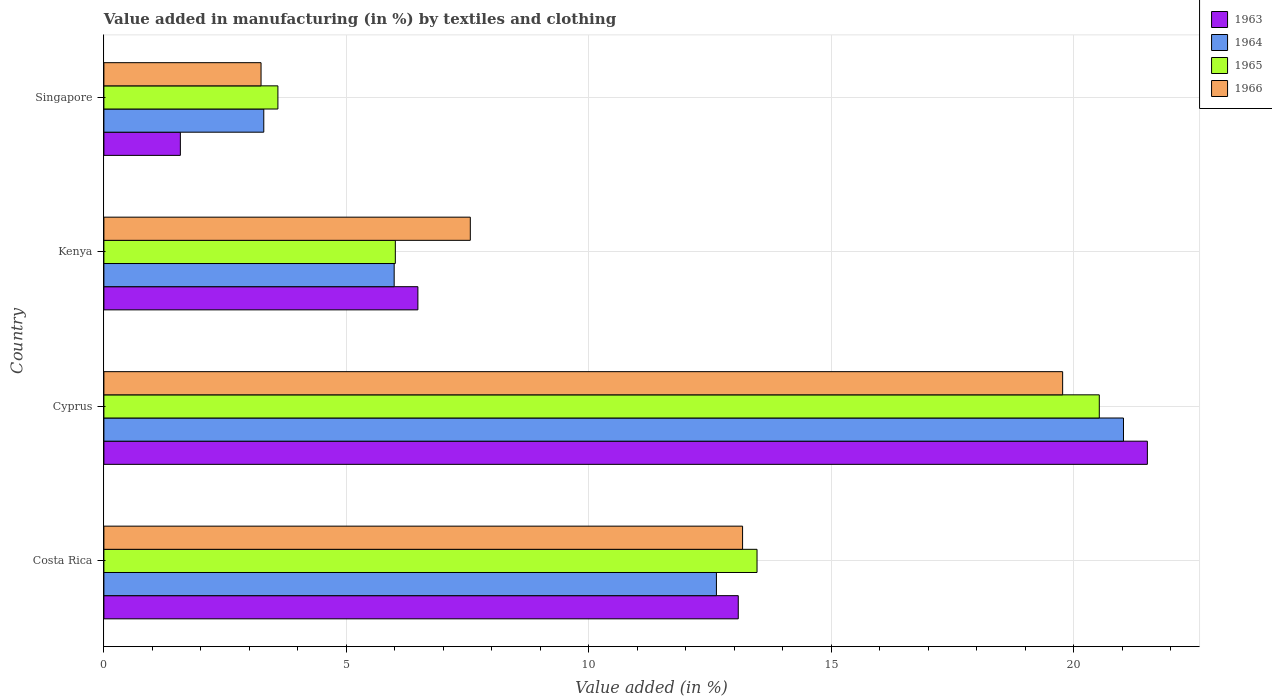How many groups of bars are there?
Your answer should be compact. 4. Are the number of bars on each tick of the Y-axis equal?
Offer a very short reply. Yes. How many bars are there on the 4th tick from the top?
Ensure brevity in your answer.  4. How many bars are there on the 4th tick from the bottom?
Your response must be concise. 4. What is the label of the 1st group of bars from the top?
Your response must be concise. Singapore. What is the percentage of value added in manufacturing by textiles and clothing in 1963 in Cyprus?
Your answer should be very brief. 21.52. Across all countries, what is the maximum percentage of value added in manufacturing by textiles and clothing in 1964?
Provide a succinct answer. 21.03. Across all countries, what is the minimum percentage of value added in manufacturing by textiles and clothing in 1964?
Provide a succinct answer. 3.3. In which country was the percentage of value added in manufacturing by textiles and clothing in 1963 maximum?
Make the answer very short. Cyprus. In which country was the percentage of value added in manufacturing by textiles and clothing in 1965 minimum?
Your answer should be very brief. Singapore. What is the total percentage of value added in manufacturing by textiles and clothing in 1963 in the graph?
Your answer should be compact. 42.66. What is the difference between the percentage of value added in manufacturing by textiles and clothing in 1966 in Cyprus and that in Singapore?
Offer a very short reply. 16.53. What is the difference between the percentage of value added in manufacturing by textiles and clothing in 1964 in Cyprus and the percentage of value added in manufacturing by textiles and clothing in 1965 in Costa Rica?
Your answer should be compact. 7.56. What is the average percentage of value added in manufacturing by textiles and clothing in 1965 per country?
Keep it short and to the point. 10.9. What is the difference between the percentage of value added in manufacturing by textiles and clothing in 1963 and percentage of value added in manufacturing by textiles and clothing in 1966 in Singapore?
Provide a short and direct response. -1.66. What is the ratio of the percentage of value added in manufacturing by textiles and clothing in 1963 in Costa Rica to that in Cyprus?
Ensure brevity in your answer.  0.61. Is the difference between the percentage of value added in manufacturing by textiles and clothing in 1963 in Cyprus and Kenya greater than the difference between the percentage of value added in manufacturing by textiles and clothing in 1966 in Cyprus and Kenya?
Offer a very short reply. Yes. What is the difference between the highest and the second highest percentage of value added in manufacturing by textiles and clothing in 1964?
Keep it short and to the point. 8.4. What is the difference between the highest and the lowest percentage of value added in manufacturing by textiles and clothing in 1965?
Offer a terse response. 16.94. In how many countries, is the percentage of value added in manufacturing by textiles and clothing in 1966 greater than the average percentage of value added in manufacturing by textiles and clothing in 1966 taken over all countries?
Provide a succinct answer. 2. Is the sum of the percentage of value added in manufacturing by textiles and clothing in 1965 in Kenya and Singapore greater than the maximum percentage of value added in manufacturing by textiles and clothing in 1963 across all countries?
Your response must be concise. No. Is it the case that in every country, the sum of the percentage of value added in manufacturing by textiles and clothing in 1963 and percentage of value added in manufacturing by textiles and clothing in 1966 is greater than the sum of percentage of value added in manufacturing by textiles and clothing in 1964 and percentage of value added in manufacturing by textiles and clothing in 1965?
Your answer should be very brief. No. What does the 1st bar from the top in Singapore represents?
Offer a terse response. 1966. What does the 4th bar from the bottom in Cyprus represents?
Offer a terse response. 1966. Are all the bars in the graph horizontal?
Give a very brief answer. Yes. What is the difference between two consecutive major ticks on the X-axis?
Give a very brief answer. 5. Are the values on the major ticks of X-axis written in scientific E-notation?
Ensure brevity in your answer.  No. Does the graph contain any zero values?
Keep it short and to the point. No. Does the graph contain grids?
Ensure brevity in your answer.  Yes. Where does the legend appear in the graph?
Make the answer very short. Top right. How many legend labels are there?
Give a very brief answer. 4. How are the legend labels stacked?
Your answer should be very brief. Vertical. What is the title of the graph?
Offer a very short reply. Value added in manufacturing (in %) by textiles and clothing. Does "1973" appear as one of the legend labels in the graph?
Your answer should be very brief. No. What is the label or title of the X-axis?
Offer a very short reply. Value added (in %). What is the label or title of the Y-axis?
Offer a terse response. Country. What is the Value added (in %) in 1963 in Costa Rica?
Provide a succinct answer. 13.08. What is the Value added (in %) in 1964 in Costa Rica?
Your answer should be very brief. 12.63. What is the Value added (in %) of 1965 in Costa Rica?
Keep it short and to the point. 13.47. What is the Value added (in %) of 1966 in Costa Rica?
Your answer should be very brief. 13.17. What is the Value added (in %) of 1963 in Cyprus?
Provide a succinct answer. 21.52. What is the Value added (in %) of 1964 in Cyprus?
Your answer should be compact. 21.03. What is the Value added (in %) of 1965 in Cyprus?
Your answer should be compact. 20.53. What is the Value added (in %) in 1966 in Cyprus?
Make the answer very short. 19.78. What is the Value added (in %) of 1963 in Kenya?
Ensure brevity in your answer.  6.48. What is the Value added (in %) in 1964 in Kenya?
Your answer should be very brief. 5.99. What is the Value added (in %) in 1965 in Kenya?
Provide a succinct answer. 6.01. What is the Value added (in %) of 1966 in Kenya?
Provide a short and direct response. 7.56. What is the Value added (in %) of 1963 in Singapore?
Offer a terse response. 1.58. What is the Value added (in %) in 1964 in Singapore?
Keep it short and to the point. 3.3. What is the Value added (in %) of 1965 in Singapore?
Offer a very short reply. 3.59. What is the Value added (in %) of 1966 in Singapore?
Your response must be concise. 3.24. Across all countries, what is the maximum Value added (in %) in 1963?
Offer a terse response. 21.52. Across all countries, what is the maximum Value added (in %) of 1964?
Keep it short and to the point. 21.03. Across all countries, what is the maximum Value added (in %) of 1965?
Make the answer very short. 20.53. Across all countries, what is the maximum Value added (in %) in 1966?
Offer a terse response. 19.78. Across all countries, what is the minimum Value added (in %) of 1963?
Offer a very short reply. 1.58. Across all countries, what is the minimum Value added (in %) of 1964?
Ensure brevity in your answer.  3.3. Across all countries, what is the minimum Value added (in %) in 1965?
Give a very brief answer. 3.59. Across all countries, what is the minimum Value added (in %) of 1966?
Ensure brevity in your answer.  3.24. What is the total Value added (in %) of 1963 in the graph?
Provide a succinct answer. 42.66. What is the total Value added (in %) of 1964 in the graph?
Offer a terse response. 42.95. What is the total Value added (in %) of 1965 in the graph?
Offer a very short reply. 43.6. What is the total Value added (in %) in 1966 in the graph?
Ensure brevity in your answer.  43.75. What is the difference between the Value added (in %) in 1963 in Costa Rica and that in Cyprus?
Your response must be concise. -8.44. What is the difference between the Value added (in %) of 1964 in Costa Rica and that in Cyprus?
Offer a very short reply. -8.4. What is the difference between the Value added (in %) of 1965 in Costa Rica and that in Cyprus?
Make the answer very short. -7.06. What is the difference between the Value added (in %) in 1966 in Costa Rica and that in Cyprus?
Your answer should be compact. -6.6. What is the difference between the Value added (in %) of 1963 in Costa Rica and that in Kenya?
Your answer should be compact. 6.61. What is the difference between the Value added (in %) of 1964 in Costa Rica and that in Kenya?
Your response must be concise. 6.65. What is the difference between the Value added (in %) of 1965 in Costa Rica and that in Kenya?
Keep it short and to the point. 7.46. What is the difference between the Value added (in %) of 1966 in Costa Rica and that in Kenya?
Ensure brevity in your answer.  5.62. What is the difference between the Value added (in %) in 1963 in Costa Rica and that in Singapore?
Offer a terse response. 11.51. What is the difference between the Value added (in %) in 1964 in Costa Rica and that in Singapore?
Provide a succinct answer. 9.34. What is the difference between the Value added (in %) in 1965 in Costa Rica and that in Singapore?
Provide a short and direct response. 9.88. What is the difference between the Value added (in %) in 1966 in Costa Rica and that in Singapore?
Give a very brief answer. 9.93. What is the difference between the Value added (in %) of 1963 in Cyprus and that in Kenya?
Keep it short and to the point. 15.05. What is the difference between the Value added (in %) in 1964 in Cyprus and that in Kenya?
Ensure brevity in your answer.  15.04. What is the difference between the Value added (in %) of 1965 in Cyprus and that in Kenya?
Make the answer very short. 14.52. What is the difference between the Value added (in %) in 1966 in Cyprus and that in Kenya?
Offer a terse response. 12.22. What is the difference between the Value added (in %) of 1963 in Cyprus and that in Singapore?
Give a very brief answer. 19.95. What is the difference between the Value added (in %) in 1964 in Cyprus and that in Singapore?
Your response must be concise. 17.73. What is the difference between the Value added (in %) of 1965 in Cyprus and that in Singapore?
Make the answer very short. 16.94. What is the difference between the Value added (in %) of 1966 in Cyprus and that in Singapore?
Provide a short and direct response. 16.53. What is the difference between the Value added (in %) in 1963 in Kenya and that in Singapore?
Ensure brevity in your answer.  4.9. What is the difference between the Value added (in %) of 1964 in Kenya and that in Singapore?
Provide a short and direct response. 2.69. What is the difference between the Value added (in %) of 1965 in Kenya and that in Singapore?
Your response must be concise. 2.42. What is the difference between the Value added (in %) in 1966 in Kenya and that in Singapore?
Your response must be concise. 4.32. What is the difference between the Value added (in %) of 1963 in Costa Rica and the Value added (in %) of 1964 in Cyprus?
Make the answer very short. -7.95. What is the difference between the Value added (in %) of 1963 in Costa Rica and the Value added (in %) of 1965 in Cyprus?
Your answer should be compact. -7.45. What is the difference between the Value added (in %) in 1963 in Costa Rica and the Value added (in %) in 1966 in Cyprus?
Make the answer very short. -6.69. What is the difference between the Value added (in %) in 1964 in Costa Rica and the Value added (in %) in 1965 in Cyprus?
Offer a very short reply. -7.9. What is the difference between the Value added (in %) of 1964 in Costa Rica and the Value added (in %) of 1966 in Cyprus?
Provide a short and direct response. -7.14. What is the difference between the Value added (in %) in 1965 in Costa Rica and the Value added (in %) in 1966 in Cyprus?
Offer a very short reply. -6.3. What is the difference between the Value added (in %) of 1963 in Costa Rica and the Value added (in %) of 1964 in Kenya?
Make the answer very short. 7.1. What is the difference between the Value added (in %) of 1963 in Costa Rica and the Value added (in %) of 1965 in Kenya?
Provide a succinct answer. 7.07. What is the difference between the Value added (in %) in 1963 in Costa Rica and the Value added (in %) in 1966 in Kenya?
Your answer should be very brief. 5.53. What is the difference between the Value added (in %) in 1964 in Costa Rica and the Value added (in %) in 1965 in Kenya?
Your response must be concise. 6.62. What is the difference between the Value added (in %) of 1964 in Costa Rica and the Value added (in %) of 1966 in Kenya?
Ensure brevity in your answer.  5.08. What is the difference between the Value added (in %) in 1965 in Costa Rica and the Value added (in %) in 1966 in Kenya?
Keep it short and to the point. 5.91. What is the difference between the Value added (in %) in 1963 in Costa Rica and the Value added (in %) in 1964 in Singapore?
Provide a short and direct response. 9.79. What is the difference between the Value added (in %) of 1963 in Costa Rica and the Value added (in %) of 1965 in Singapore?
Ensure brevity in your answer.  9.5. What is the difference between the Value added (in %) in 1963 in Costa Rica and the Value added (in %) in 1966 in Singapore?
Provide a succinct answer. 9.84. What is the difference between the Value added (in %) of 1964 in Costa Rica and the Value added (in %) of 1965 in Singapore?
Ensure brevity in your answer.  9.04. What is the difference between the Value added (in %) in 1964 in Costa Rica and the Value added (in %) in 1966 in Singapore?
Your answer should be compact. 9.39. What is the difference between the Value added (in %) of 1965 in Costa Rica and the Value added (in %) of 1966 in Singapore?
Your answer should be very brief. 10.23. What is the difference between the Value added (in %) of 1963 in Cyprus and the Value added (in %) of 1964 in Kenya?
Give a very brief answer. 15.54. What is the difference between the Value added (in %) of 1963 in Cyprus and the Value added (in %) of 1965 in Kenya?
Provide a short and direct response. 15.51. What is the difference between the Value added (in %) of 1963 in Cyprus and the Value added (in %) of 1966 in Kenya?
Offer a very short reply. 13.97. What is the difference between the Value added (in %) of 1964 in Cyprus and the Value added (in %) of 1965 in Kenya?
Make the answer very short. 15.02. What is the difference between the Value added (in %) in 1964 in Cyprus and the Value added (in %) in 1966 in Kenya?
Your response must be concise. 13.47. What is the difference between the Value added (in %) of 1965 in Cyprus and the Value added (in %) of 1966 in Kenya?
Give a very brief answer. 12.97. What is the difference between the Value added (in %) of 1963 in Cyprus and the Value added (in %) of 1964 in Singapore?
Offer a very short reply. 18.23. What is the difference between the Value added (in %) of 1963 in Cyprus and the Value added (in %) of 1965 in Singapore?
Offer a terse response. 17.93. What is the difference between the Value added (in %) in 1963 in Cyprus and the Value added (in %) in 1966 in Singapore?
Your answer should be very brief. 18.28. What is the difference between the Value added (in %) in 1964 in Cyprus and the Value added (in %) in 1965 in Singapore?
Give a very brief answer. 17.44. What is the difference between the Value added (in %) of 1964 in Cyprus and the Value added (in %) of 1966 in Singapore?
Offer a terse response. 17.79. What is the difference between the Value added (in %) in 1965 in Cyprus and the Value added (in %) in 1966 in Singapore?
Make the answer very short. 17.29. What is the difference between the Value added (in %) of 1963 in Kenya and the Value added (in %) of 1964 in Singapore?
Make the answer very short. 3.18. What is the difference between the Value added (in %) of 1963 in Kenya and the Value added (in %) of 1965 in Singapore?
Your answer should be compact. 2.89. What is the difference between the Value added (in %) in 1963 in Kenya and the Value added (in %) in 1966 in Singapore?
Keep it short and to the point. 3.24. What is the difference between the Value added (in %) of 1964 in Kenya and the Value added (in %) of 1965 in Singapore?
Your answer should be very brief. 2.4. What is the difference between the Value added (in %) of 1964 in Kenya and the Value added (in %) of 1966 in Singapore?
Your answer should be very brief. 2.75. What is the difference between the Value added (in %) in 1965 in Kenya and the Value added (in %) in 1966 in Singapore?
Keep it short and to the point. 2.77. What is the average Value added (in %) of 1963 per country?
Your response must be concise. 10.67. What is the average Value added (in %) in 1964 per country?
Keep it short and to the point. 10.74. What is the average Value added (in %) of 1965 per country?
Make the answer very short. 10.9. What is the average Value added (in %) of 1966 per country?
Your response must be concise. 10.94. What is the difference between the Value added (in %) in 1963 and Value added (in %) in 1964 in Costa Rica?
Keep it short and to the point. 0.45. What is the difference between the Value added (in %) of 1963 and Value added (in %) of 1965 in Costa Rica?
Your response must be concise. -0.39. What is the difference between the Value added (in %) of 1963 and Value added (in %) of 1966 in Costa Rica?
Your answer should be compact. -0.09. What is the difference between the Value added (in %) of 1964 and Value added (in %) of 1965 in Costa Rica?
Offer a terse response. -0.84. What is the difference between the Value added (in %) of 1964 and Value added (in %) of 1966 in Costa Rica?
Keep it short and to the point. -0.54. What is the difference between the Value added (in %) in 1965 and Value added (in %) in 1966 in Costa Rica?
Offer a very short reply. 0.3. What is the difference between the Value added (in %) in 1963 and Value added (in %) in 1964 in Cyprus?
Provide a succinct answer. 0.49. What is the difference between the Value added (in %) of 1963 and Value added (in %) of 1966 in Cyprus?
Your response must be concise. 1.75. What is the difference between the Value added (in %) of 1964 and Value added (in %) of 1965 in Cyprus?
Ensure brevity in your answer.  0.5. What is the difference between the Value added (in %) in 1964 and Value added (in %) in 1966 in Cyprus?
Your answer should be compact. 1.25. What is the difference between the Value added (in %) of 1965 and Value added (in %) of 1966 in Cyprus?
Provide a succinct answer. 0.76. What is the difference between the Value added (in %) in 1963 and Value added (in %) in 1964 in Kenya?
Ensure brevity in your answer.  0.49. What is the difference between the Value added (in %) of 1963 and Value added (in %) of 1965 in Kenya?
Provide a succinct answer. 0.47. What is the difference between the Value added (in %) in 1963 and Value added (in %) in 1966 in Kenya?
Make the answer very short. -1.08. What is the difference between the Value added (in %) in 1964 and Value added (in %) in 1965 in Kenya?
Offer a terse response. -0.02. What is the difference between the Value added (in %) of 1964 and Value added (in %) of 1966 in Kenya?
Your answer should be very brief. -1.57. What is the difference between the Value added (in %) of 1965 and Value added (in %) of 1966 in Kenya?
Your answer should be compact. -1.55. What is the difference between the Value added (in %) of 1963 and Value added (in %) of 1964 in Singapore?
Provide a succinct answer. -1.72. What is the difference between the Value added (in %) in 1963 and Value added (in %) in 1965 in Singapore?
Ensure brevity in your answer.  -2.01. What is the difference between the Value added (in %) in 1963 and Value added (in %) in 1966 in Singapore?
Provide a succinct answer. -1.66. What is the difference between the Value added (in %) of 1964 and Value added (in %) of 1965 in Singapore?
Your answer should be compact. -0.29. What is the difference between the Value added (in %) in 1964 and Value added (in %) in 1966 in Singapore?
Your answer should be compact. 0.06. What is the difference between the Value added (in %) of 1965 and Value added (in %) of 1966 in Singapore?
Offer a very short reply. 0.35. What is the ratio of the Value added (in %) in 1963 in Costa Rica to that in Cyprus?
Your answer should be compact. 0.61. What is the ratio of the Value added (in %) of 1964 in Costa Rica to that in Cyprus?
Give a very brief answer. 0.6. What is the ratio of the Value added (in %) of 1965 in Costa Rica to that in Cyprus?
Provide a succinct answer. 0.66. What is the ratio of the Value added (in %) of 1966 in Costa Rica to that in Cyprus?
Provide a short and direct response. 0.67. What is the ratio of the Value added (in %) of 1963 in Costa Rica to that in Kenya?
Keep it short and to the point. 2.02. What is the ratio of the Value added (in %) in 1964 in Costa Rica to that in Kenya?
Keep it short and to the point. 2.11. What is the ratio of the Value added (in %) of 1965 in Costa Rica to that in Kenya?
Make the answer very short. 2.24. What is the ratio of the Value added (in %) of 1966 in Costa Rica to that in Kenya?
Give a very brief answer. 1.74. What is the ratio of the Value added (in %) of 1963 in Costa Rica to that in Singapore?
Offer a very short reply. 8.3. What is the ratio of the Value added (in %) in 1964 in Costa Rica to that in Singapore?
Give a very brief answer. 3.83. What is the ratio of the Value added (in %) of 1965 in Costa Rica to that in Singapore?
Provide a succinct answer. 3.75. What is the ratio of the Value added (in %) in 1966 in Costa Rica to that in Singapore?
Keep it short and to the point. 4.06. What is the ratio of the Value added (in %) in 1963 in Cyprus to that in Kenya?
Your answer should be compact. 3.32. What is the ratio of the Value added (in %) in 1964 in Cyprus to that in Kenya?
Your response must be concise. 3.51. What is the ratio of the Value added (in %) in 1965 in Cyprus to that in Kenya?
Provide a succinct answer. 3.42. What is the ratio of the Value added (in %) in 1966 in Cyprus to that in Kenya?
Ensure brevity in your answer.  2.62. What is the ratio of the Value added (in %) in 1963 in Cyprus to that in Singapore?
Provide a succinct answer. 13.65. What is the ratio of the Value added (in %) of 1964 in Cyprus to that in Singapore?
Keep it short and to the point. 6.38. What is the ratio of the Value added (in %) of 1965 in Cyprus to that in Singapore?
Your answer should be compact. 5.72. What is the ratio of the Value added (in %) in 1966 in Cyprus to that in Singapore?
Offer a very short reply. 6.1. What is the ratio of the Value added (in %) of 1963 in Kenya to that in Singapore?
Make the answer very short. 4.11. What is the ratio of the Value added (in %) of 1964 in Kenya to that in Singapore?
Provide a short and direct response. 1.82. What is the ratio of the Value added (in %) of 1965 in Kenya to that in Singapore?
Ensure brevity in your answer.  1.67. What is the ratio of the Value added (in %) in 1966 in Kenya to that in Singapore?
Provide a succinct answer. 2.33. What is the difference between the highest and the second highest Value added (in %) of 1963?
Ensure brevity in your answer.  8.44. What is the difference between the highest and the second highest Value added (in %) of 1964?
Your answer should be compact. 8.4. What is the difference between the highest and the second highest Value added (in %) in 1965?
Your response must be concise. 7.06. What is the difference between the highest and the second highest Value added (in %) of 1966?
Keep it short and to the point. 6.6. What is the difference between the highest and the lowest Value added (in %) of 1963?
Offer a terse response. 19.95. What is the difference between the highest and the lowest Value added (in %) of 1964?
Ensure brevity in your answer.  17.73. What is the difference between the highest and the lowest Value added (in %) of 1965?
Offer a terse response. 16.94. What is the difference between the highest and the lowest Value added (in %) in 1966?
Your answer should be compact. 16.53. 